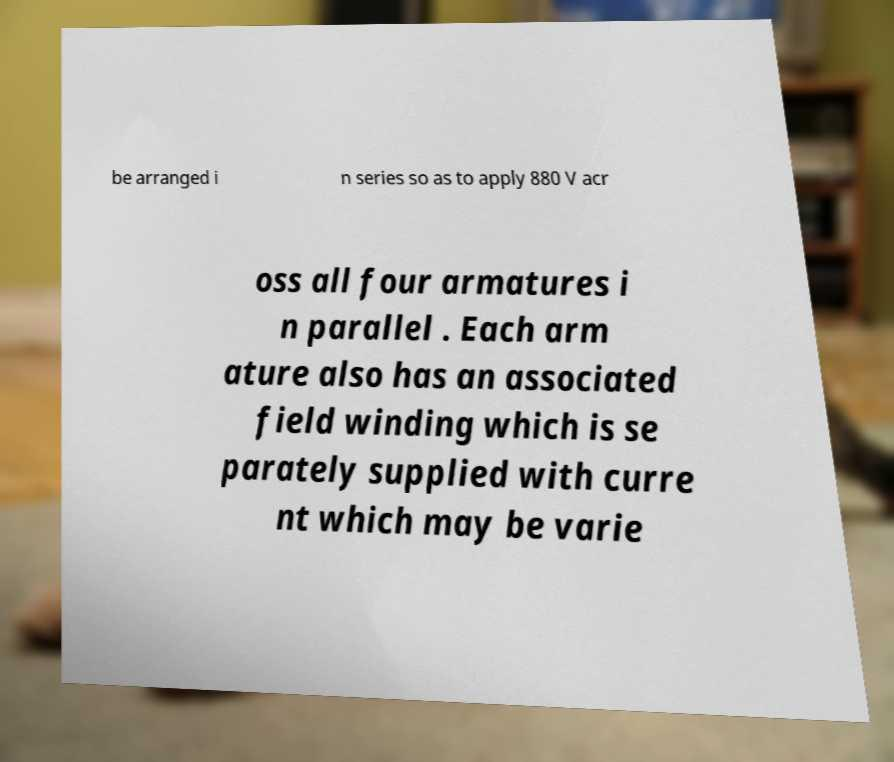Please identify and transcribe the text found in this image. be arranged i n series so as to apply 880 V acr oss all four armatures i n parallel . Each arm ature also has an associated field winding which is se parately supplied with curre nt which may be varie 